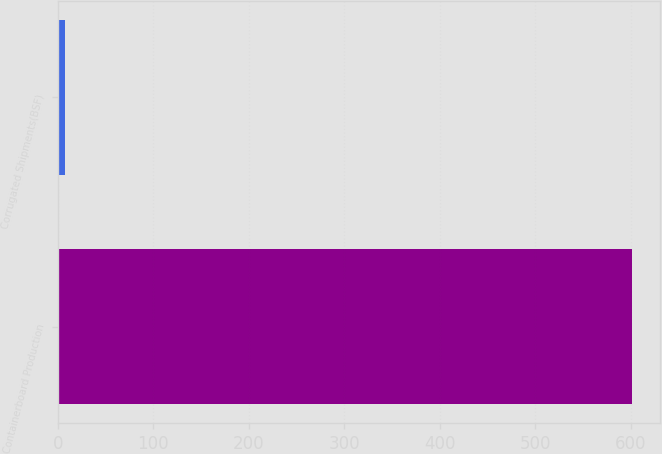Convert chart. <chart><loc_0><loc_0><loc_500><loc_500><bar_chart><fcel>Containerboard Production<fcel>Corrugated Shipments(BSF)<nl><fcel>601<fcel>8<nl></chart> 